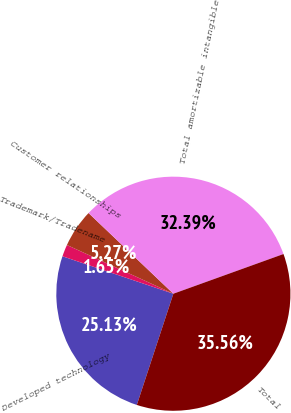<chart> <loc_0><loc_0><loc_500><loc_500><pie_chart><fcel>Developed technology<fcel>Trademark/Tradename<fcel>Customer relationships<fcel>Total amortizable intangible<fcel>Total<nl><fcel>25.13%<fcel>1.65%<fcel>5.27%<fcel>32.39%<fcel>35.56%<nl></chart> 